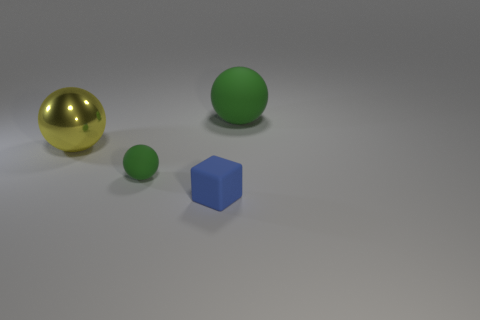Add 4 tiny blue objects. How many objects exist? 8 Subtract all big rubber spheres. How many spheres are left? 2 Subtract 0 cyan cylinders. How many objects are left? 4 Subtract all spheres. How many objects are left? 1 Subtract 1 cubes. How many cubes are left? 0 Subtract all cyan balls. Subtract all blue cylinders. How many balls are left? 3 Subtract all green cylinders. How many brown balls are left? 0 Subtract all big purple matte blocks. Subtract all big yellow metallic balls. How many objects are left? 3 Add 2 big green objects. How many big green objects are left? 3 Add 4 large red matte balls. How many large red matte balls exist? 4 